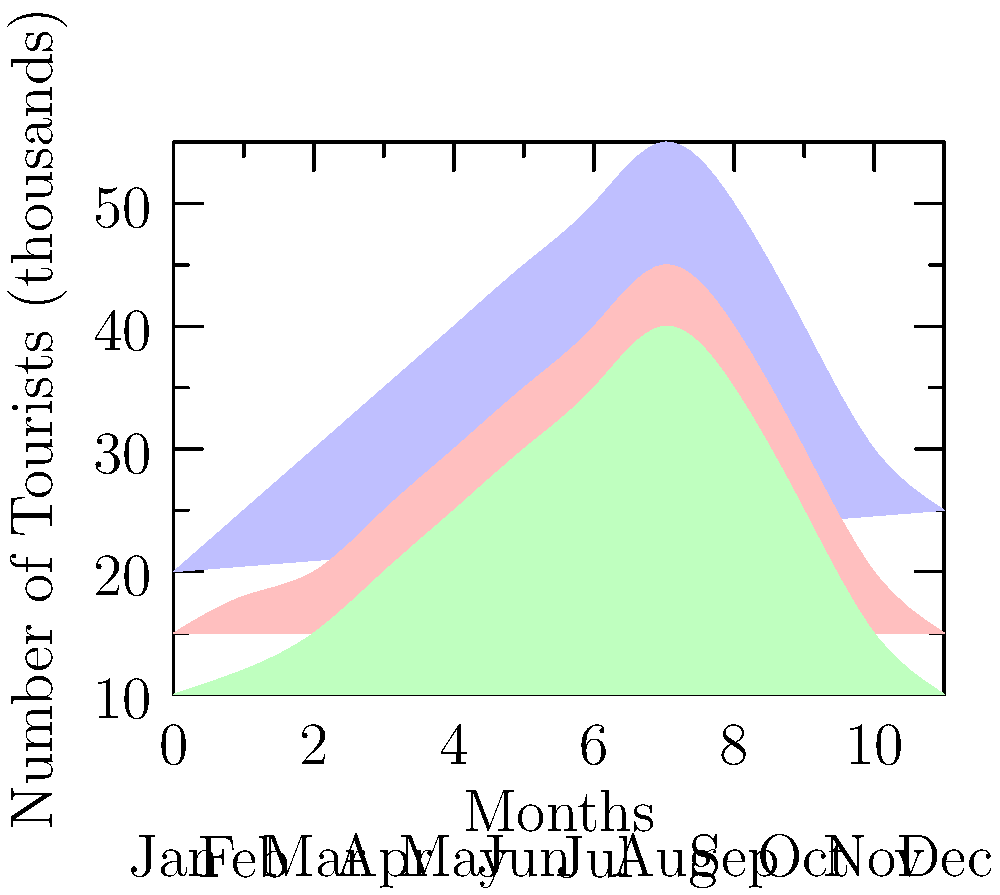As the CEO of a luxury hotel group, you're analyzing the seasonal distribution of international tourists. The stacked area chart shows the number of tourists from different regions throughout the year. During which month does the combined number of tourists from all regions reach its peak, and what strategic decision would you consider based on this information? To answer this question, we need to analyze the stacked area chart:

1. The chart shows tourist numbers from three regions: Americas (blue), Asia (red), and Europe (green).
2. We need to identify the month where the total height of all three stacked areas is at its maximum.
3. Examining the chart, we can see that the combined height reaches its peak in August (the 8th month).
4. The strategic decision should be based on maximizing revenue during this peak period.

Given this information, a strategic decision could be:

5. Implement peak season pricing in August to maximize revenue.
6. Ensure full staffing and resources to handle the increased number of guests.
7. Develop special packages or events to attract even more tourists during this prime month.
8. Consider partnerships with airlines or travel agencies to promote your hotels during this peak period.

The most comprehensive strategic decision would be to implement a dynamic pricing strategy that increases rates in August while ensuring top-notch service and unique offerings to justify the premium pricing.
Answer: August; Implement dynamic pricing and enhanced services 